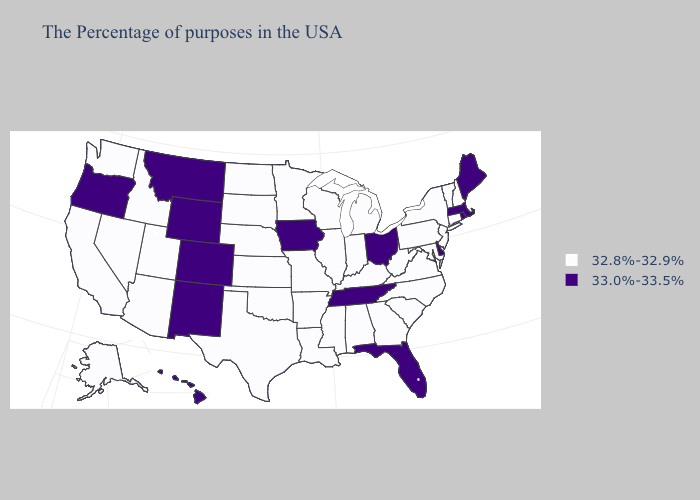What is the highest value in the USA?
Quick response, please. 33.0%-33.5%. What is the value of Missouri?
Quick response, please. 32.8%-32.9%. Does Arkansas have a lower value than Missouri?
Give a very brief answer. No. Does Maine have the highest value in the USA?
Write a very short answer. Yes. Name the states that have a value in the range 33.0%-33.5%?
Give a very brief answer. Maine, Massachusetts, Rhode Island, Delaware, Ohio, Florida, Tennessee, Iowa, Wyoming, Colorado, New Mexico, Montana, Oregon, Hawaii. Does Utah have the lowest value in the USA?
Write a very short answer. Yes. What is the value of Nebraska?
Short answer required. 32.8%-32.9%. What is the value of Wyoming?
Quick response, please. 33.0%-33.5%. Which states have the highest value in the USA?
Answer briefly. Maine, Massachusetts, Rhode Island, Delaware, Ohio, Florida, Tennessee, Iowa, Wyoming, Colorado, New Mexico, Montana, Oregon, Hawaii. What is the value of Massachusetts?
Concise answer only. 33.0%-33.5%. How many symbols are there in the legend?
Quick response, please. 2. What is the value of Mississippi?
Quick response, please. 32.8%-32.9%. What is the highest value in the USA?
Answer briefly. 33.0%-33.5%. Which states hav the highest value in the MidWest?
Write a very short answer. Ohio, Iowa. Which states hav the highest value in the West?
Give a very brief answer. Wyoming, Colorado, New Mexico, Montana, Oregon, Hawaii. 